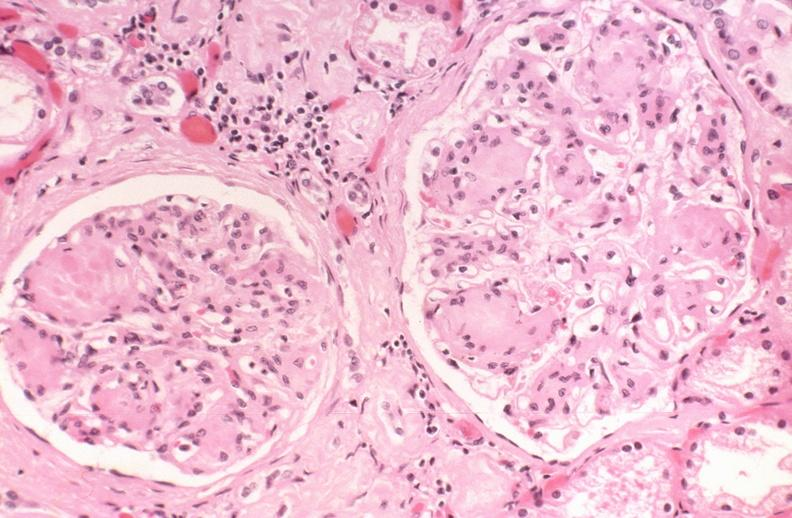does this image show kidney glomerulus, kimmelstiel-wilson nodules in a patient with diabetes mellitus?
Answer the question using a single word or phrase. Yes 